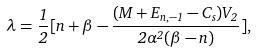Convert formula to latex. <formula><loc_0><loc_0><loc_500><loc_500>\lambda = \frac { 1 } { 2 } [ n + \beta - \frac { ( M + E _ { n , - 1 } - C _ { s } ) V _ { 2 } } { 2 \alpha ^ { 2 } ( \beta - n ) } ] ,</formula> 